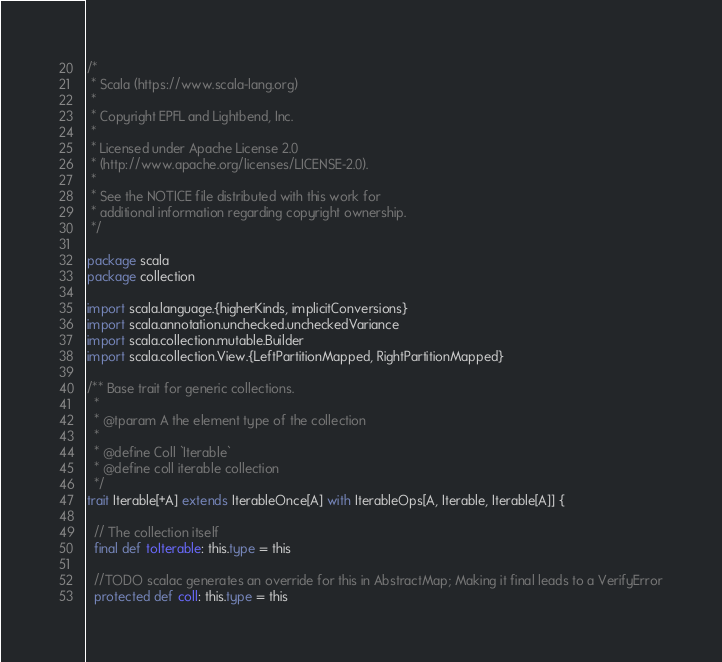<code> <loc_0><loc_0><loc_500><loc_500><_Scala_>/*
 * Scala (https://www.scala-lang.org)
 *
 * Copyright EPFL and Lightbend, Inc.
 *
 * Licensed under Apache License 2.0
 * (http://www.apache.org/licenses/LICENSE-2.0).
 *
 * See the NOTICE file distributed with this work for
 * additional information regarding copyright ownership.
 */

package scala
package collection

import scala.language.{higherKinds, implicitConversions}
import scala.annotation.unchecked.uncheckedVariance
import scala.collection.mutable.Builder
import scala.collection.View.{LeftPartitionMapped, RightPartitionMapped}

/** Base trait for generic collections.
  *
  * @tparam A the element type of the collection
  *
  * @define Coll `Iterable`
  * @define coll iterable collection
  */
trait Iterable[+A] extends IterableOnce[A] with IterableOps[A, Iterable, Iterable[A]] {

  // The collection itself
  final def toIterable: this.type = this

  //TODO scalac generates an override for this in AbstractMap; Making it final leads to a VerifyError
  protected def coll: this.type = this
</code> 